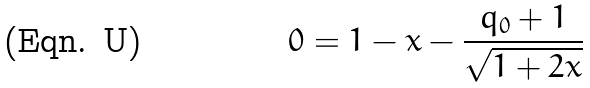<formula> <loc_0><loc_0><loc_500><loc_500>0 = 1 - x - \frac { q _ { 0 } + 1 } { \sqrt { 1 + 2 x } }</formula> 